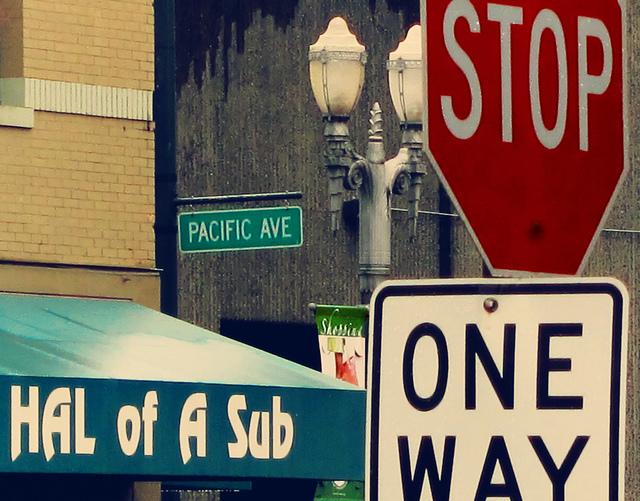Is the brick building painted?
Keep it brief. Yes. What color is the word stop written in?
Give a very brief answer. White. What is the name of the street at this intersection?
Keep it brief. Pacific ave. 